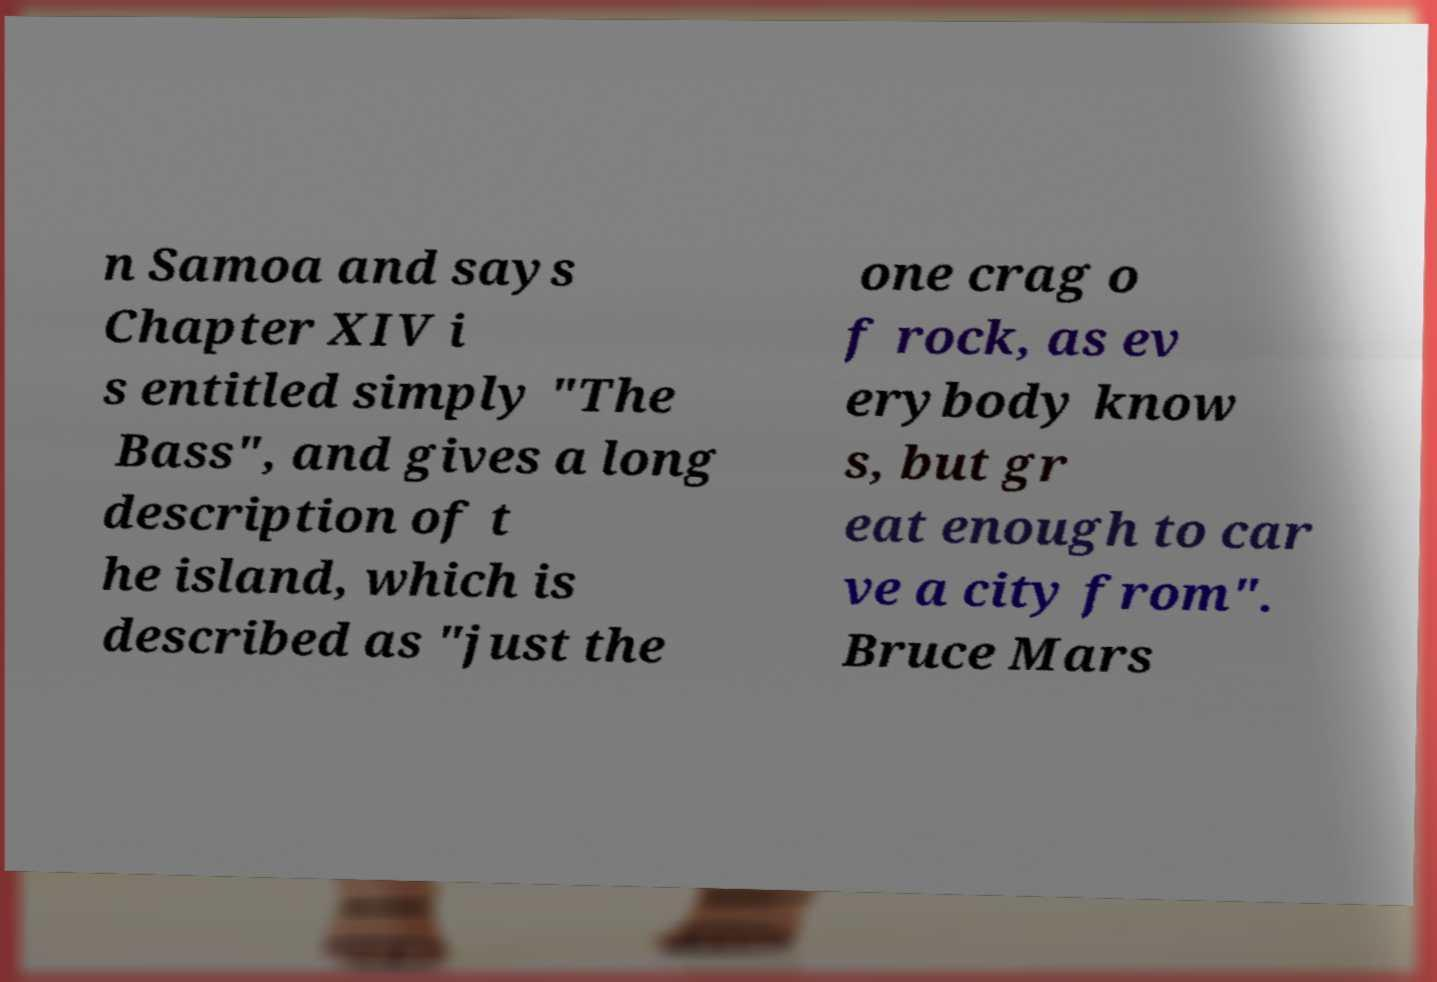Can you read and provide the text displayed in the image?This photo seems to have some interesting text. Can you extract and type it out for me? n Samoa and says Chapter XIV i s entitled simply "The Bass", and gives a long description of t he island, which is described as "just the one crag o f rock, as ev erybody know s, but gr eat enough to car ve a city from". Bruce Mars 